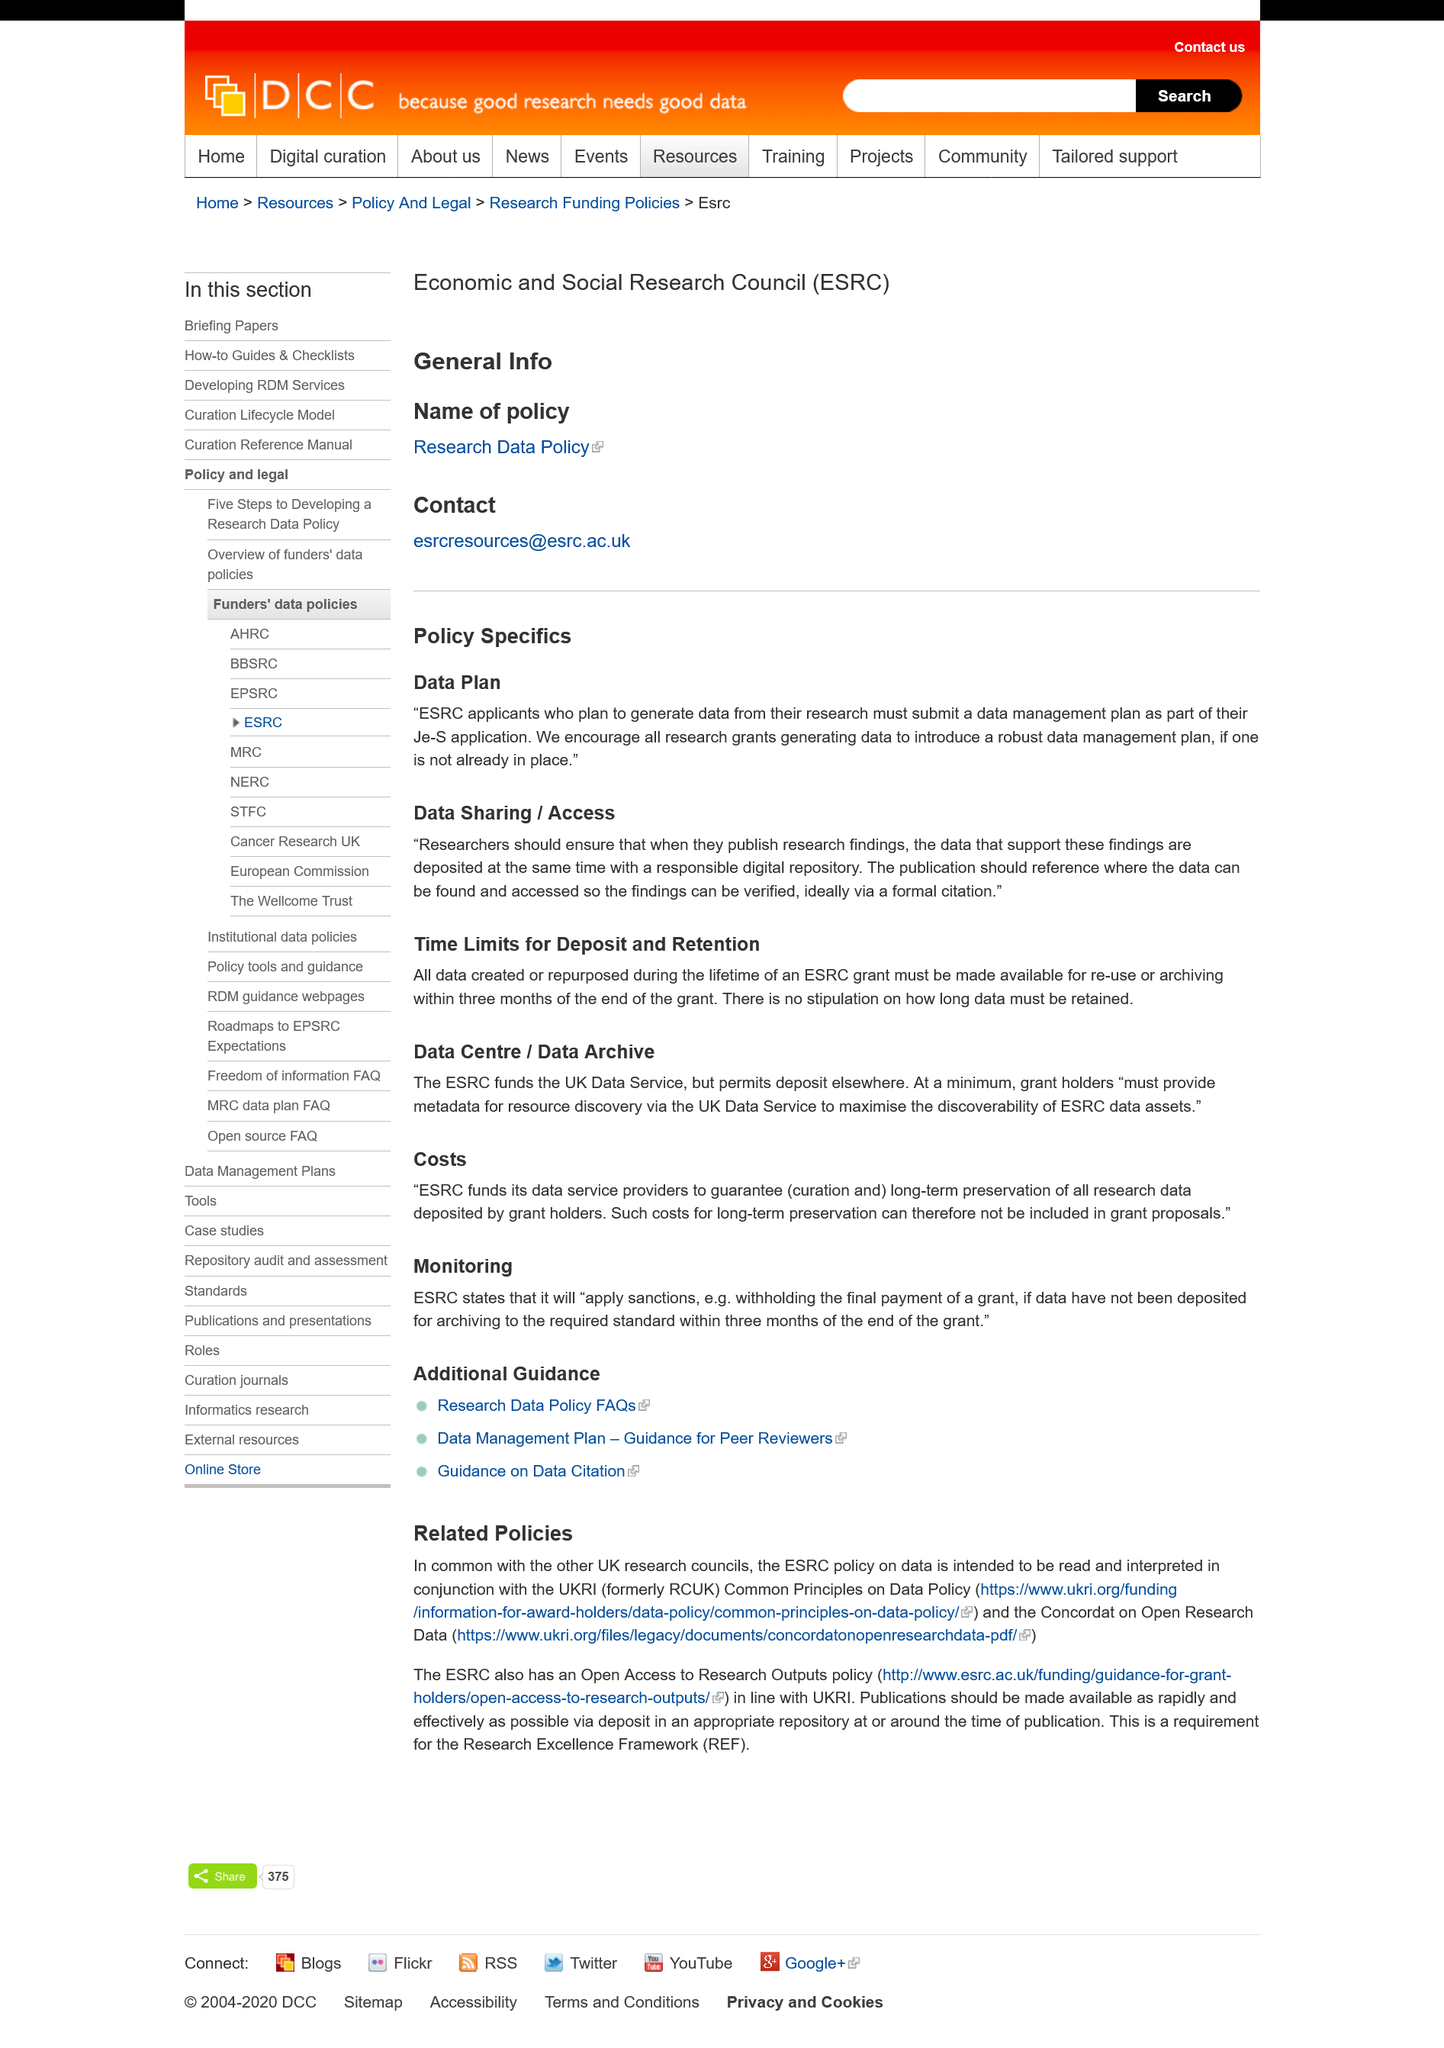List a handful of essential elements in this visual. Applicants for the Economic and Social Research Council (ESRC) must submit a data management plan as part of their Je-S application. All data from the ESRC grant must be made available within three months from the end of the project. There is no stipulation regarding the retention of data from an ESRC grant, as indicated by the response 'No.' 